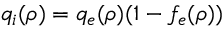Convert formula to latex. <formula><loc_0><loc_0><loc_500><loc_500>q _ { i } ( \rho ) = q _ { e } ( \rho ) ( 1 - f _ { e } ( \rho ) )</formula> 